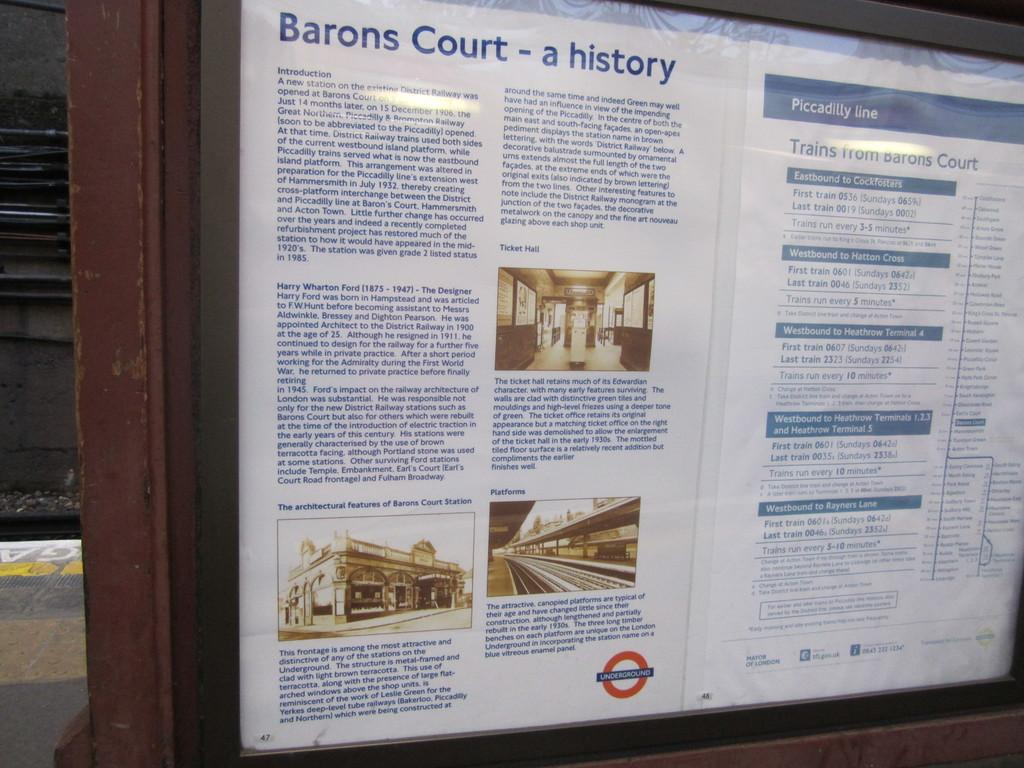Provide a one-sentence caption for the provided image. An outdoor informational sign details the history of Barons Court. 